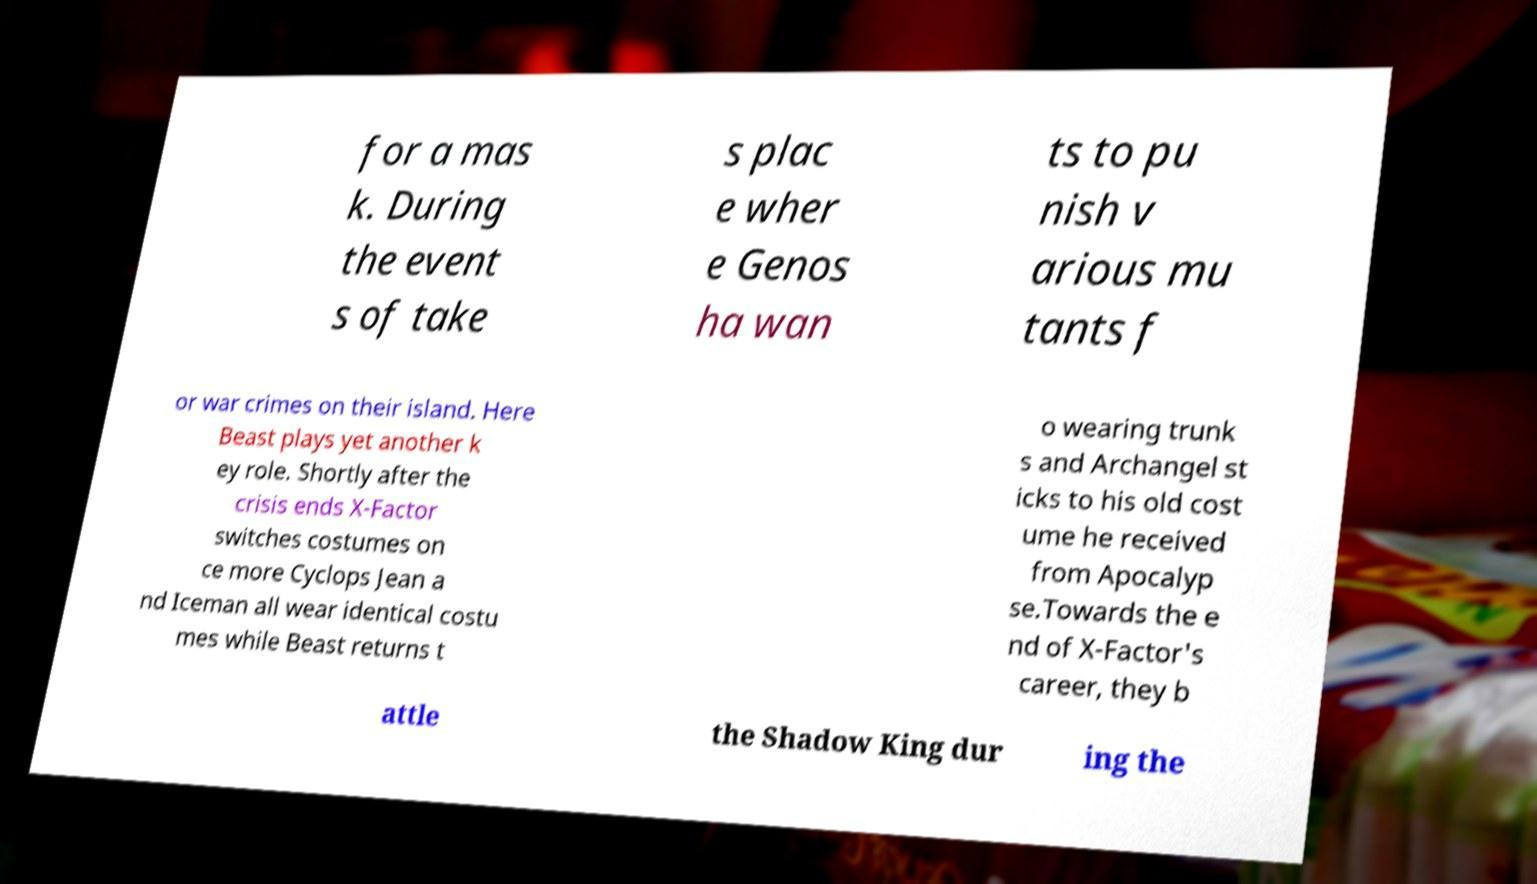I need the written content from this picture converted into text. Can you do that? for a mas k. During the event s of take s plac e wher e Genos ha wan ts to pu nish v arious mu tants f or war crimes on their island. Here Beast plays yet another k ey role. Shortly after the crisis ends X-Factor switches costumes on ce more Cyclops Jean a nd Iceman all wear identical costu mes while Beast returns t o wearing trunk s and Archangel st icks to his old cost ume he received from Apocalyp se.Towards the e nd of X-Factor's career, they b attle the Shadow King dur ing the 